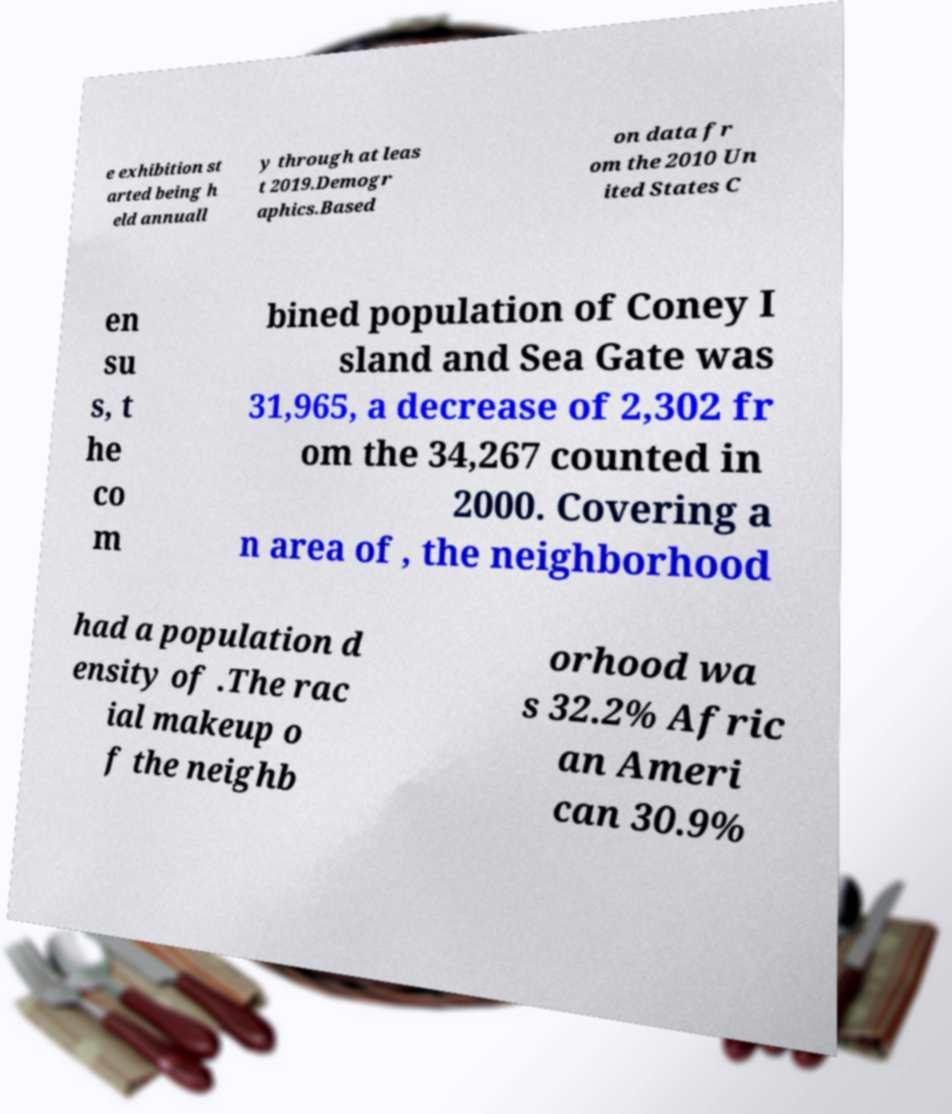What messages or text are displayed in this image? I need them in a readable, typed format. e exhibition st arted being h eld annuall y through at leas t 2019.Demogr aphics.Based on data fr om the 2010 Un ited States C en su s, t he co m bined population of Coney I sland and Sea Gate was 31,965, a decrease of 2,302 fr om the 34,267 counted in 2000. Covering a n area of , the neighborhood had a population d ensity of .The rac ial makeup o f the neighb orhood wa s 32.2% Afric an Ameri can 30.9% 